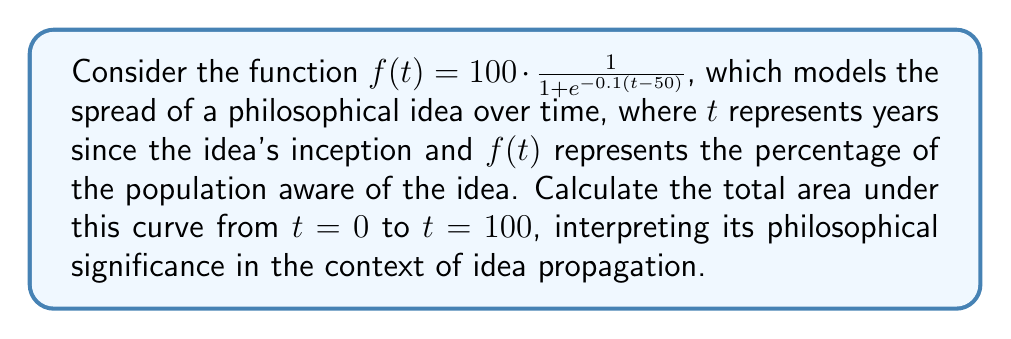Teach me how to tackle this problem. To solve this problem, we need to integrate the given function over the specified interval. This requires the use of the logistic function integral.

1) First, let's set up the definite integral:

   $$\int_{0}^{100} 100 \cdot \frac{1}{1 + e^{-0.1(t-50)}} dt$$

2) This is a logistic function with the following parameters:
   $L = 100$ (maximum value)
   $k = 0.1$ (steepness)
   $t_0 = 50$ (midpoint)

3) The integral of a logistic function is given by:

   $$\int \frac{L}{1 + e^{-k(t-t_0)}} dt = \frac{L}{k} \ln(1 + e^{k(t-t_0)}) + C$$

4) Applying this to our definite integral:

   $$\left[\frac{100}{0.1} \ln(1 + e^{0.1(t-50)})\right]_{0}^{100}$$

5) Evaluating at the limits:

   $$\frac{1000}{0.1} \ln(1 + e^{0.1(100-50)}) - \frac{1000}{0.1} \ln(1 + e^{0.1(0-50)})$$

6) Simplifying:

   $$10000 \ln(1 + e^5) - 10000 \ln(1 + e^{-5})$$

7) Calculate the result:

   $$10000 \ln(149.4131591) - 10000 \ln(1.0067167) \approx 7324.0820$$

Philosophical interpretation: The area under this curve represents the cumulative awareness of the idea over time. A value of approximately 7324 "idea-years" suggests a significant impact of the philosophical concept, indicating its persistent influence and gradual saturation in societal consciousness over the century.
Answer: The area under the curve from $t=0$ to $t=100$ is approximately 7324.0820 idea-years. 